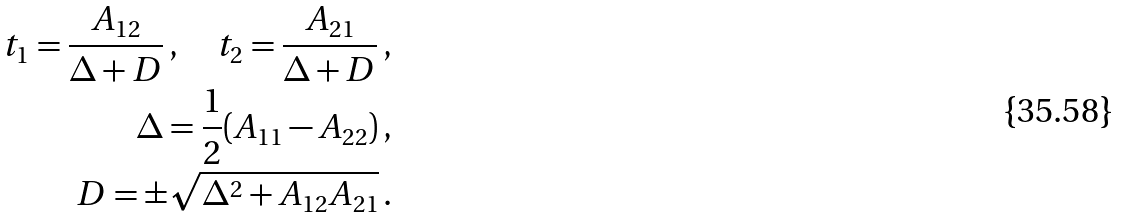Convert formula to latex. <formula><loc_0><loc_0><loc_500><loc_500>t _ { 1 } = \frac { A _ { 1 2 } } { \Delta + D } \, , \quad t _ { 2 } = \frac { A _ { 2 1 } } { \Delta + D } \, , \\ \Delta = \frac { 1 } { 2 } ( A _ { 1 1 } - A _ { 2 2 } ) \, , \\ D = \pm \sqrt { \Delta ^ { 2 } + A _ { 1 2 } A _ { 2 1 } } \, .</formula> 